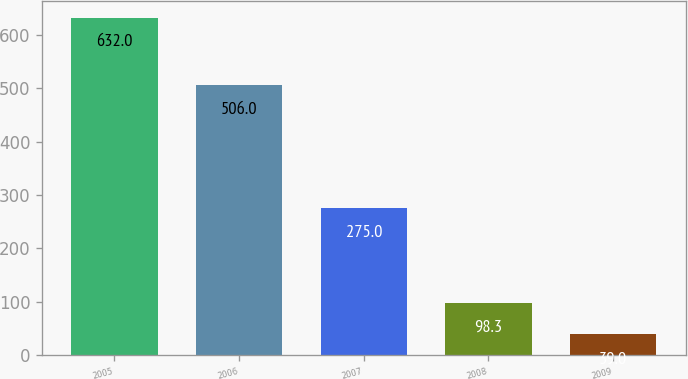<chart> <loc_0><loc_0><loc_500><loc_500><bar_chart><fcel>2005<fcel>2006<fcel>2007<fcel>2008<fcel>2009<nl><fcel>632<fcel>506<fcel>275<fcel>98.3<fcel>39<nl></chart> 